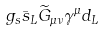Convert formula to latex. <formula><loc_0><loc_0><loc_500><loc_500>g _ { s } \bar { s } _ { L } { \widetilde { G } } _ { \mu \nu } \gamma ^ { \mu } d _ { L }</formula> 